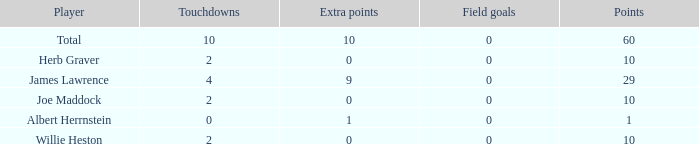What is the highest number of extra points for players with less than 2 touchdowns and less than 1 point? None. 